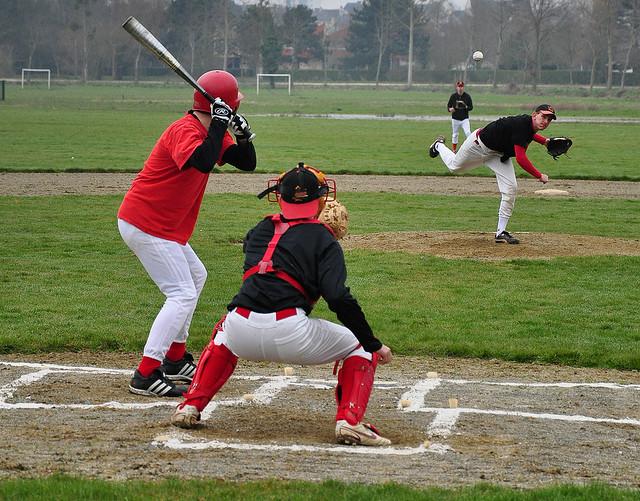What color shirt is the batter wearing?
Be succinct. Red. Is the batter waiting to hit the ball?
Concise answer only. Yes. How many people are standing in the grass?
Concise answer only. 1. 